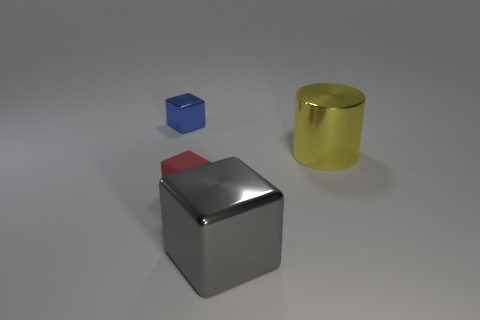Is there any other thing that is the same shape as the big yellow metal object?
Your answer should be compact. No. How many things are yellow shiny things or metallic cubes to the right of the small blue thing?
Keep it short and to the point. 2. Is the number of big metal things less than the number of objects?
Keep it short and to the point. Yes. The small thing that is right of the tiny block on the left side of the tiny cube that is right of the tiny blue thing is what color?
Make the answer very short. Red. Do the small blue thing and the gray block have the same material?
Offer a terse response. Yes. There is a large metal block; how many tiny blue shiny objects are behind it?
Your answer should be compact. 1. The gray metal thing that is the same shape as the blue thing is what size?
Keep it short and to the point. Large. How many yellow objects are either small metallic cubes or shiny cylinders?
Your response must be concise. 1. What number of objects are on the left side of the metal thing in front of the yellow cylinder?
Provide a short and direct response. 2. How many other objects are the same shape as the big yellow thing?
Offer a very short reply. 0. 